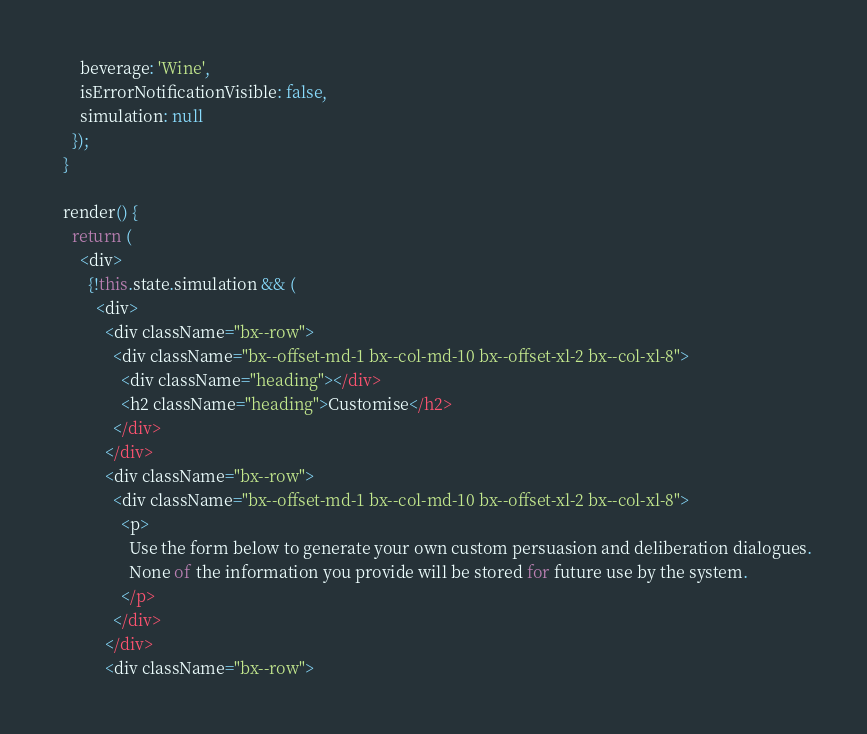Convert code to text. <code><loc_0><loc_0><loc_500><loc_500><_JavaScript_>      beverage: 'Wine',
      isErrorNotificationVisible: false,
      simulation: null
    });
  }

  render() {
    return (
      <div>
        {!this.state.simulation && (
          <div>
            <div className="bx--row">
              <div className="bx--offset-md-1 bx--col-md-10 bx--offset-xl-2 bx--col-xl-8">
                <div className="heading"></div>
                <h2 className="heading">Customise</h2>
              </div>
            </div>
            <div className="bx--row">
              <div className="bx--offset-md-1 bx--col-md-10 bx--offset-xl-2 bx--col-xl-8">
                <p>
                  Use the form below to generate your own custom persuasion and deliberation dialogues.
                  None of the information you provide will be stored for future use by the system.
                </p>
              </div>
            </div>
            <div className="bx--row"></code> 